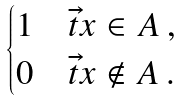<formula> <loc_0><loc_0><loc_500><loc_500>\begin{cases} 1 & \vec { t } { x } \in A \, , \\ 0 & \vec { t } { x } \not \in A \, . \\ \end{cases}</formula> 